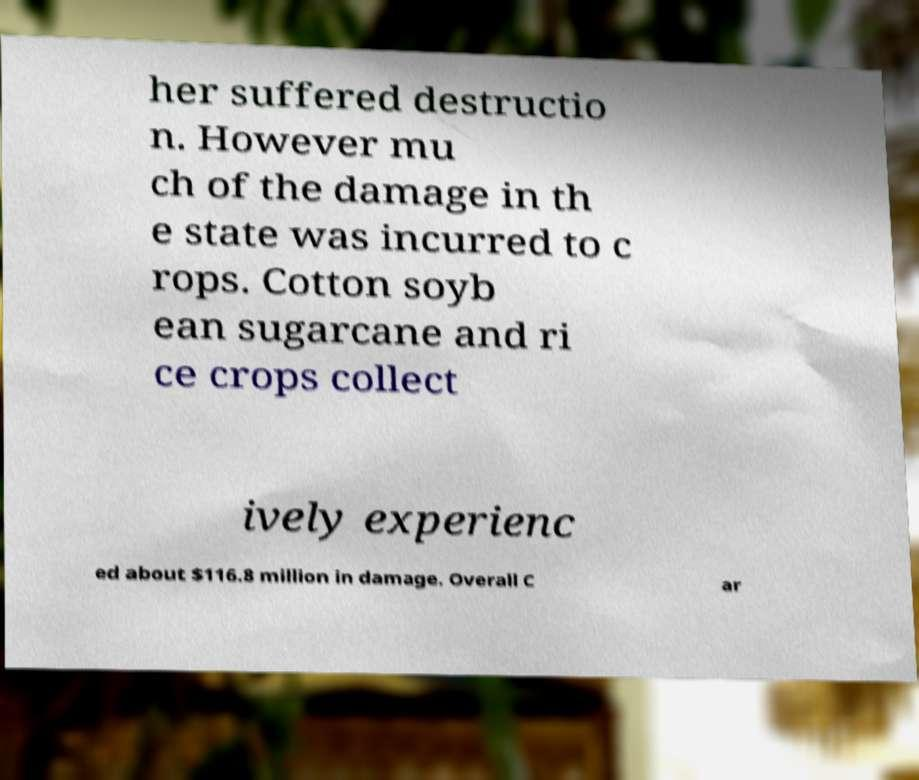Can you accurately transcribe the text from the provided image for me? her suffered destructio n. However mu ch of the damage in th e state was incurred to c rops. Cotton soyb ean sugarcane and ri ce crops collect ively experienc ed about $116.8 million in damage. Overall C ar 